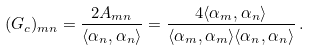Convert formula to latex. <formula><loc_0><loc_0><loc_500><loc_500>( G _ { c } ) _ { m n } = { \frac { 2 A _ { m n } } { \langle \alpha _ { n } , \alpha _ { n } \rangle } } = \frac { 4 \langle \alpha _ { m } , \alpha _ { n } \rangle } { \langle \alpha _ { m } , \alpha _ { m } \rangle \langle \alpha _ { n } , \alpha _ { n } \rangle } \, .</formula> 